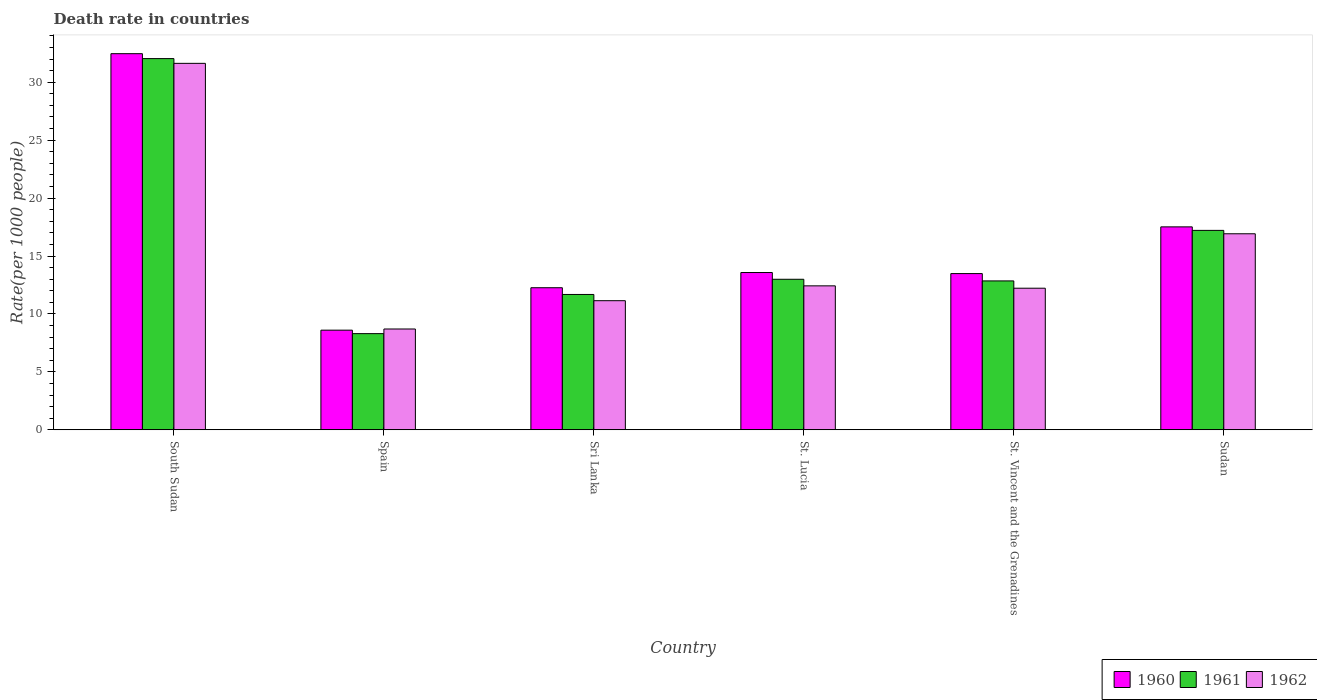How many groups of bars are there?
Your answer should be very brief. 6. Are the number of bars per tick equal to the number of legend labels?
Offer a terse response. Yes. How many bars are there on the 6th tick from the left?
Offer a terse response. 3. What is the label of the 4th group of bars from the left?
Give a very brief answer. St. Lucia. What is the death rate in 1960 in South Sudan?
Offer a very short reply. 32.46. Across all countries, what is the maximum death rate in 1961?
Provide a short and direct response. 32.04. Across all countries, what is the minimum death rate in 1961?
Offer a terse response. 8.3. In which country was the death rate in 1962 maximum?
Provide a short and direct response. South Sudan. What is the total death rate in 1961 in the graph?
Your answer should be compact. 95.07. What is the difference between the death rate in 1962 in South Sudan and that in Spain?
Provide a short and direct response. 22.93. What is the difference between the death rate in 1960 in St. Lucia and the death rate in 1962 in Spain?
Your response must be concise. 4.87. What is the average death rate in 1960 per country?
Provide a short and direct response. 16.32. What is the difference between the death rate of/in 1960 and death rate of/in 1962 in Spain?
Keep it short and to the point. -0.1. What is the ratio of the death rate in 1962 in St. Lucia to that in Sudan?
Make the answer very short. 0.73. Is the death rate in 1960 in St. Lucia less than that in St. Vincent and the Grenadines?
Offer a very short reply. No. What is the difference between the highest and the second highest death rate in 1961?
Offer a terse response. 14.83. What is the difference between the highest and the lowest death rate in 1962?
Make the answer very short. 22.93. What does the 2nd bar from the left in Sudan represents?
Give a very brief answer. 1961. What is the difference between two consecutive major ticks on the Y-axis?
Your response must be concise. 5. Are the values on the major ticks of Y-axis written in scientific E-notation?
Keep it short and to the point. No. Does the graph contain any zero values?
Your answer should be very brief. No. How are the legend labels stacked?
Give a very brief answer. Horizontal. What is the title of the graph?
Your answer should be very brief. Death rate in countries. Does "1975" appear as one of the legend labels in the graph?
Provide a short and direct response. No. What is the label or title of the Y-axis?
Provide a short and direct response. Rate(per 1000 people). What is the Rate(per 1000 people) in 1960 in South Sudan?
Your answer should be compact. 32.46. What is the Rate(per 1000 people) in 1961 in South Sudan?
Provide a short and direct response. 32.04. What is the Rate(per 1000 people) in 1962 in South Sudan?
Give a very brief answer. 31.63. What is the Rate(per 1000 people) in 1960 in Spain?
Your answer should be very brief. 8.6. What is the Rate(per 1000 people) of 1960 in Sri Lanka?
Your response must be concise. 12.26. What is the Rate(per 1000 people) of 1961 in Sri Lanka?
Provide a succinct answer. 11.68. What is the Rate(per 1000 people) in 1962 in Sri Lanka?
Provide a short and direct response. 11.14. What is the Rate(per 1000 people) of 1960 in St. Lucia?
Your answer should be very brief. 13.57. What is the Rate(per 1000 people) in 1961 in St. Lucia?
Provide a short and direct response. 12.99. What is the Rate(per 1000 people) in 1962 in St. Lucia?
Ensure brevity in your answer.  12.42. What is the Rate(per 1000 people) in 1960 in St. Vincent and the Grenadines?
Give a very brief answer. 13.48. What is the Rate(per 1000 people) of 1961 in St. Vincent and the Grenadines?
Your answer should be compact. 12.85. What is the Rate(per 1000 people) in 1962 in St. Vincent and the Grenadines?
Make the answer very short. 12.22. What is the Rate(per 1000 people) in 1960 in Sudan?
Your answer should be compact. 17.51. What is the Rate(per 1000 people) of 1961 in Sudan?
Your response must be concise. 17.21. What is the Rate(per 1000 people) in 1962 in Sudan?
Offer a very short reply. 16.92. Across all countries, what is the maximum Rate(per 1000 people) of 1960?
Provide a short and direct response. 32.46. Across all countries, what is the maximum Rate(per 1000 people) in 1961?
Ensure brevity in your answer.  32.04. Across all countries, what is the maximum Rate(per 1000 people) of 1962?
Offer a terse response. 31.63. Across all countries, what is the minimum Rate(per 1000 people) in 1960?
Provide a short and direct response. 8.6. What is the total Rate(per 1000 people) of 1960 in the graph?
Provide a short and direct response. 97.89. What is the total Rate(per 1000 people) of 1961 in the graph?
Provide a short and direct response. 95.07. What is the total Rate(per 1000 people) in 1962 in the graph?
Your answer should be compact. 93.03. What is the difference between the Rate(per 1000 people) of 1960 in South Sudan and that in Spain?
Make the answer very short. 23.86. What is the difference between the Rate(per 1000 people) in 1961 in South Sudan and that in Spain?
Offer a terse response. 23.74. What is the difference between the Rate(per 1000 people) in 1962 in South Sudan and that in Spain?
Provide a succinct answer. 22.93. What is the difference between the Rate(per 1000 people) in 1960 in South Sudan and that in Sri Lanka?
Give a very brief answer. 20.2. What is the difference between the Rate(per 1000 people) of 1961 in South Sudan and that in Sri Lanka?
Make the answer very short. 20.36. What is the difference between the Rate(per 1000 people) in 1962 in South Sudan and that in Sri Lanka?
Offer a very short reply. 20.48. What is the difference between the Rate(per 1000 people) of 1960 in South Sudan and that in St. Lucia?
Provide a short and direct response. 18.89. What is the difference between the Rate(per 1000 people) of 1961 in South Sudan and that in St. Lucia?
Keep it short and to the point. 19.05. What is the difference between the Rate(per 1000 people) of 1962 in South Sudan and that in St. Lucia?
Your answer should be compact. 19.2. What is the difference between the Rate(per 1000 people) in 1960 in South Sudan and that in St. Vincent and the Grenadines?
Keep it short and to the point. 18.98. What is the difference between the Rate(per 1000 people) of 1961 in South Sudan and that in St. Vincent and the Grenadines?
Offer a very short reply. 19.19. What is the difference between the Rate(per 1000 people) in 1962 in South Sudan and that in St. Vincent and the Grenadines?
Keep it short and to the point. 19.41. What is the difference between the Rate(per 1000 people) in 1960 in South Sudan and that in Sudan?
Provide a short and direct response. 14.95. What is the difference between the Rate(per 1000 people) of 1961 in South Sudan and that in Sudan?
Provide a short and direct response. 14.83. What is the difference between the Rate(per 1000 people) of 1962 in South Sudan and that in Sudan?
Your answer should be compact. 14.71. What is the difference between the Rate(per 1000 people) in 1960 in Spain and that in Sri Lanka?
Offer a very short reply. -3.66. What is the difference between the Rate(per 1000 people) of 1961 in Spain and that in Sri Lanka?
Offer a terse response. -3.38. What is the difference between the Rate(per 1000 people) in 1962 in Spain and that in Sri Lanka?
Make the answer very short. -2.44. What is the difference between the Rate(per 1000 people) of 1960 in Spain and that in St. Lucia?
Your response must be concise. -4.97. What is the difference between the Rate(per 1000 people) in 1961 in Spain and that in St. Lucia?
Your response must be concise. -4.69. What is the difference between the Rate(per 1000 people) in 1962 in Spain and that in St. Lucia?
Provide a short and direct response. -3.72. What is the difference between the Rate(per 1000 people) of 1960 in Spain and that in St. Vincent and the Grenadines?
Your answer should be compact. -4.88. What is the difference between the Rate(per 1000 people) in 1961 in Spain and that in St. Vincent and the Grenadines?
Provide a succinct answer. -4.55. What is the difference between the Rate(per 1000 people) in 1962 in Spain and that in St. Vincent and the Grenadines?
Your answer should be very brief. -3.52. What is the difference between the Rate(per 1000 people) of 1960 in Spain and that in Sudan?
Provide a short and direct response. -8.91. What is the difference between the Rate(per 1000 people) of 1961 in Spain and that in Sudan?
Keep it short and to the point. -8.91. What is the difference between the Rate(per 1000 people) in 1962 in Spain and that in Sudan?
Keep it short and to the point. -8.22. What is the difference between the Rate(per 1000 people) in 1960 in Sri Lanka and that in St. Lucia?
Your answer should be compact. -1.31. What is the difference between the Rate(per 1000 people) of 1961 in Sri Lanka and that in St. Lucia?
Keep it short and to the point. -1.31. What is the difference between the Rate(per 1000 people) in 1962 in Sri Lanka and that in St. Lucia?
Ensure brevity in your answer.  -1.28. What is the difference between the Rate(per 1000 people) in 1960 in Sri Lanka and that in St. Vincent and the Grenadines?
Offer a terse response. -1.22. What is the difference between the Rate(per 1000 people) in 1961 in Sri Lanka and that in St. Vincent and the Grenadines?
Give a very brief answer. -1.17. What is the difference between the Rate(per 1000 people) in 1962 in Sri Lanka and that in St. Vincent and the Grenadines?
Ensure brevity in your answer.  -1.08. What is the difference between the Rate(per 1000 people) of 1960 in Sri Lanka and that in Sudan?
Offer a very short reply. -5.25. What is the difference between the Rate(per 1000 people) of 1961 in Sri Lanka and that in Sudan?
Your answer should be very brief. -5.53. What is the difference between the Rate(per 1000 people) of 1962 in Sri Lanka and that in Sudan?
Ensure brevity in your answer.  -5.78. What is the difference between the Rate(per 1000 people) in 1960 in St. Lucia and that in St. Vincent and the Grenadines?
Offer a very short reply. 0.09. What is the difference between the Rate(per 1000 people) in 1961 in St. Lucia and that in St. Vincent and the Grenadines?
Your answer should be very brief. 0.14. What is the difference between the Rate(per 1000 people) in 1962 in St. Lucia and that in St. Vincent and the Grenadines?
Provide a succinct answer. 0.2. What is the difference between the Rate(per 1000 people) in 1960 in St. Lucia and that in Sudan?
Keep it short and to the point. -3.94. What is the difference between the Rate(per 1000 people) in 1961 in St. Lucia and that in Sudan?
Your response must be concise. -4.22. What is the difference between the Rate(per 1000 people) in 1962 in St. Lucia and that in Sudan?
Make the answer very short. -4.49. What is the difference between the Rate(per 1000 people) in 1960 in St. Vincent and the Grenadines and that in Sudan?
Give a very brief answer. -4.03. What is the difference between the Rate(per 1000 people) in 1961 in St. Vincent and the Grenadines and that in Sudan?
Your answer should be compact. -4.36. What is the difference between the Rate(per 1000 people) in 1962 in St. Vincent and the Grenadines and that in Sudan?
Ensure brevity in your answer.  -4.7. What is the difference between the Rate(per 1000 people) of 1960 in South Sudan and the Rate(per 1000 people) of 1961 in Spain?
Provide a succinct answer. 24.16. What is the difference between the Rate(per 1000 people) of 1960 in South Sudan and the Rate(per 1000 people) of 1962 in Spain?
Offer a very short reply. 23.76. What is the difference between the Rate(per 1000 people) of 1961 in South Sudan and the Rate(per 1000 people) of 1962 in Spain?
Your answer should be very brief. 23.34. What is the difference between the Rate(per 1000 people) in 1960 in South Sudan and the Rate(per 1000 people) in 1961 in Sri Lanka?
Your response must be concise. 20.78. What is the difference between the Rate(per 1000 people) of 1960 in South Sudan and the Rate(per 1000 people) of 1962 in Sri Lanka?
Your response must be concise. 21.32. What is the difference between the Rate(per 1000 people) in 1961 in South Sudan and the Rate(per 1000 people) in 1962 in Sri Lanka?
Your answer should be very brief. 20.89. What is the difference between the Rate(per 1000 people) in 1960 in South Sudan and the Rate(per 1000 people) in 1961 in St. Lucia?
Provide a succinct answer. 19.47. What is the difference between the Rate(per 1000 people) of 1960 in South Sudan and the Rate(per 1000 people) of 1962 in St. Lucia?
Your response must be concise. 20.04. What is the difference between the Rate(per 1000 people) in 1961 in South Sudan and the Rate(per 1000 people) in 1962 in St. Lucia?
Give a very brief answer. 19.61. What is the difference between the Rate(per 1000 people) in 1960 in South Sudan and the Rate(per 1000 people) in 1961 in St. Vincent and the Grenadines?
Provide a short and direct response. 19.61. What is the difference between the Rate(per 1000 people) of 1960 in South Sudan and the Rate(per 1000 people) of 1962 in St. Vincent and the Grenadines?
Your answer should be compact. 20.24. What is the difference between the Rate(per 1000 people) in 1961 in South Sudan and the Rate(per 1000 people) in 1962 in St. Vincent and the Grenadines?
Your response must be concise. 19.82. What is the difference between the Rate(per 1000 people) of 1960 in South Sudan and the Rate(per 1000 people) of 1961 in Sudan?
Offer a terse response. 15.25. What is the difference between the Rate(per 1000 people) in 1960 in South Sudan and the Rate(per 1000 people) in 1962 in Sudan?
Your response must be concise. 15.54. What is the difference between the Rate(per 1000 people) in 1961 in South Sudan and the Rate(per 1000 people) in 1962 in Sudan?
Provide a succinct answer. 15.12. What is the difference between the Rate(per 1000 people) in 1960 in Spain and the Rate(per 1000 people) in 1961 in Sri Lanka?
Your answer should be very brief. -3.08. What is the difference between the Rate(per 1000 people) in 1960 in Spain and the Rate(per 1000 people) in 1962 in Sri Lanka?
Ensure brevity in your answer.  -2.54. What is the difference between the Rate(per 1000 people) in 1961 in Spain and the Rate(per 1000 people) in 1962 in Sri Lanka?
Provide a short and direct response. -2.84. What is the difference between the Rate(per 1000 people) in 1960 in Spain and the Rate(per 1000 people) in 1961 in St. Lucia?
Provide a short and direct response. -4.39. What is the difference between the Rate(per 1000 people) in 1960 in Spain and the Rate(per 1000 people) in 1962 in St. Lucia?
Offer a very short reply. -3.82. What is the difference between the Rate(per 1000 people) of 1961 in Spain and the Rate(per 1000 people) of 1962 in St. Lucia?
Provide a short and direct response. -4.12. What is the difference between the Rate(per 1000 people) of 1960 in Spain and the Rate(per 1000 people) of 1961 in St. Vincent and the Grenadines?
Ensure brevity in your answer.  -4.25. What is the difference between the Rate(per 1000 people) of 1960 in Spain and the Rate(per 1000 people) of 1962 in St. Vincent and the Grenadines?
Provide a short and direct response. -3.62. What is the difference between the Rate(per 1000 people) of 1961 in Spain and the Rate(per 1000 people) of 1962 in St. Vincent and the Grenadines?
Your answer should be very brief. -3.92. What is the difference between the Rate(per 1000 people) in 1960 in Spain and the Rate(per 1000 people) in 1961 in Sudan?
Ensure brevity in your answer.  -8.61. What is the difference between the Rate(per 1000 people) of 1960 in Spain and the Rate(per 1000 people) of 1962 in Sudan?
Keep it short and to the point. -8.32. What is the difference between the Rate(per 1000 people) of 1961 in Spain and the Rate(per 1000 people) of 1962 in Sudan?
Your answer should be very brief. -8.62. What is the difference between the Rate(per 1000 people) in 1960 in Sri Lanka and the Rate(per 1000 people) in 1961 in St. Lucia?
Your answer should be very brief. -0.73. What is the difference between the Rate(per 1000 people) of 1960 in Sri Lanka and the Rate(per 1000 people) of 1962 in St. Lucia?
Ensure brevity in your answer.  -0.16. What is the difference between the Rate(per 1000 people) of 1961 in Sri Lanka and the Rate(per 1000 people) of 1962 in St. Lucia?
Provide a succinct answer. -0.74. What is the difference between the Rate(per 1000 people) of 1960 in Sri Lanka and the Rate(per 1000 people) of 1961 in St. Vincent and the Grenadines?
Your answer should be very brief. -0.59. What is the difference between the Rate(per 1000 people) of 1960 in Sri Lanka and the Rate(per 1000 people) of 1962 in St. Vincent and the Grenadines?
Provide a succinct answer. 0.04. What is the difference between the Rate(per 1000 people) of 1961 in Sri Lanka and the Rate(per 1000 people) of 1962 in St. Vincent and the Grenadines?
Your answer should be compact. -0.54. What is the difference between the Rate(per 1000 people) of 1960 in Sri Lanka and the Rate(per 1000 people) of 1961 in Sudan?
Keep it short and to the point. -4.95. What is the difference between the Rate(per 1000 people) in 1960 in Sri Lanka and the Rate(per 1000 people) in 1962 in Sudan?
Offer a terse response. -4.66. What is the difference between the Rate(per 1000 people) of 1961 in Sri Lanka and the Rate(per 1000 people) of 1962 in Sudan?
Ensure brevity in your answer.  -5.24. What is the difference between the Rate(per 1000 people) in 1960 in St. Lucia and the Rate(per 1000 people) in 1961 in St. Vincent and the Grenadines?
Your response must be concise. 0.72. What is the difference between the Rate(per 1000 people) of 1960 in St. Lucia and the Rate(per 1000 people) of 1962 in St. Vincent and the Grenadines?
Offer a terse response. 1.35. What is the difference between the Rate(per 1000 people) of 1961 in St. Lucia and the Rate(per 1000 people) of 1962 in St. Vincent and the Grenadines?
Ensure brevity in your answer.  0.77. What is the difference between the Rate(per 1000 people) in 1960 in St. Lucia and the Rate(per 1000 people) in 1961 in Sudan?
Keep it short and to the point. -3.64. What is the difference between the Rate(per 1000 people) of 1960 in St. Lucia and the Rate(per 1000 people) of 1962 in Sudan?
Make the answer very short. -3.34. What is the difference between the Rate(per 1000 people) of 1961 in St. Lucia and the Rate(per 1000 people) of 1962 in Sudan?
Keep it short and to the point. -3.93. What is the difference between the Rate(per 1000 people) of 1960 in St. Vincent and the Grenadines and the Rate(per 1000 people) of 1961 in Sudan?
Offer a very short reply. -3.73. What is the difference between the Rate(per 1000 people) of 1960 in St. Vincent and the Grenadines and the Rate(per 1000 people) of 1962 in Sudan?
Offer a very short reply. -3.44. What is the difference between the Rate(per 1000 people) in 1961 in St. Vincent and the Grenadines and the Rate(per 1000 people) in 1962 in Sudan?
Offer a very short reply. -4.07. What is the average Rate(per 1000 people) of 1960 per country?
Keep it short and to the point. 16.32. What is the average Rate(per 1000 people) of 1961 per country?
Your response must be concise. 15.85. What is the average Rate(per 1000 people) in 1962 per country?
Ensure brevity in your answer.  15.51. What is the difference between the Rate(per 1000 people) in 1960 and Rate(per 1000 people) in 1961 in South Sudan?
Make the answer very short. 0.42. What is the difference between the Rate(per 1000 people) of 1960 and Rate(per 1000 people) of 1962 in South Sudan?
Keep it short and to the point. 0.83. What is the difference between the Rate(per 1000 people) in 1961 and Rate(per 1000 people) in 1962 in South Sudan?
Make the answer very short. 0.41. What is the difference between the Rate(per 1000 people) in 1960 and Rate(per 1000 people) in 1962 in Spain?
Give a very brief answer. -0.1. What is the difference between the Rate(per 1000 people) in 1961 and Rate(per 1000 people) in 1962 in Spain?
Your answer should be compact. -0.4. What is the difference between the Rate(per 1000 people) of 1960 and Rate(per 1000 people) of 1961 in Sri Lanka?
Your answer should be compact. 0.58. What is the difference between the Rate(per 1000 people) in 1960 and Rate(per 1000 people) in 1962 in Sri Lanka?
Offer a very short reply. 1.12. What is the difference between the Rate(per 1000 people) in 1961 and Rate(per 1000 people) in 1962 in Sri Lanka?
Provide a short and direct response. 0.54. What is the difference between the Rate(per 1000 people) in 1960 and Rate(per 1000 people) in 1961 in St. Lucia?
Keep it short and to the point. 0.58. What is the difference between the Rate(per 1000 people) of 1960 and Rate(per 1000 people) of 1962 in St. Lucia?
Your response must be concise. 1.15. What is the difference between the Rate(per 1000 people) in 1961 and Rate(per 1000 people) in 1962 in St. Lucia?
Make the answer very short. 0.57. What is the difference between the Rate(per 1000 people) of 1960 and Rate(per 1000 people) of 1961 in St. Vincent and the Grenadines?
Keep it short and to the point. 0.63. What is the difference between the Rate(per 1000 people) of 1960 and Rate(per 1000 people) of 1962 in St. Vincent and the Grenadines?
Keep it short and to the point. 1.26. What is the difference between the Rate(per 1000 people) in 1961 and Rate(per 1000 people) in 1962 in St. Vincent and the Grenadines?
Your answer should be compact. 0.63. What is the difference between the Rate(per 1000 people) in 1960 and Rate(per 1000 people) in 1961 in Sudan?
Ensure brevity in your answer.  0.3. What is the difference between the Rate(per 1000 people) of 1960 and Rate(per 1000 people) of 1962 in Sudan?
Your response must be concise. 0.6. What is the difference between the Rate(per 1000 people) of 1961 and Rate(per 1000 people) of 1962 in Sudan?
Your response must be concise. 0.29. What is the ratio of the Rate(per 1000 people) in 1960 in South Sudan to that in Spain?
Offer a terse response. 3.77. What is the ratio of the Rate(per 1000 people) in 1961 in South Sudan to that in Spain?
Provide a short and direct response. 3.86. What is the ratio of the Rate(per 1000 people) of 1962 in South Sudan to that in Spain?
Keep it short and to the point. 3.64. What is the ratio of the Rate(per 1000 people) in 1960 in South Sudan to that in Sri Lanka?
Ensure brevity in your answer.  2.65. What is the ratio of the Rate(per 1000 people) of 1961 in South Sudan to that in Sri Lanka?
Your answer should be compact. 2.74. What is the ratio of the Rate(per 1000 people) of 1962 in South Sudan to that in Sri Lanka?
Your answer should be very brief. 2.84. What is the ratio of the Rate(per 1000 people) of 1960 in South Sudan to that in St. Lucia?
Your answer should be very brief. 2.39. What is the ratio of the Rate(per 1000 people) of 1961 in South Sudan to that in St. Lucia?
Offer a terse response. 2.47. What is the ratio of the Rate(per 1000 people) of 1962 in South Sudan to that in St. Lucia?
Make the answer very short. 2.55. What is the ratio of the Rate(per 1000 people) in 1960 in South Sudan to that in St. Vincent and the Grenadines?
Keep it short and to the point. 2.41. What is the ratio of the Rate(per 1000 people) of 1961 in South Sudan to that in St. Vincent and the Grenadines?
Offer a very short reply. 2.49. What is the ratio of the Rate(per 1000 people) in 1962 in South Sudan to that in St. Vincent and the Grenadines?
Keep it short and to the point. 2.59. What is the ratio of the Rate(per 1000 people) of 1960 in South Sudan to that in Sudan?
Offer a very short reply. 1.85. What is the ratio of the Rate(per 1000 people) in 1961 in South Sudan to that in Sudan?
Keep it short and to the point. 1.86. What is the ratio of the Rate(per 1000 people) of 1962 in South Sudan to that in Sudan?
Make the answer very short. 1.87. What is the ratio of the Rate(per 1000 people) in 1960 in Spain to that in Sri Lanka?
Make the answer very short. 0.7. What is the ratio of the Rate(per 1000 people) of 1961 in Spain to that in Sri Lanka?
Offer a very short reply. 0.71. What is the ratio of the Rate(per 1000 people) of 1962 in Spain to that in Sri Lanka?
Offer a very short reply. 0.78. What is the ratio of the Rate(per 1000 people) of 1960 in Spain to that in St. Lucia?
Your response must be concise. 0.63. What is the ratio of the Rate(per 1000 people) of 1961 in Spain to that in St. Lucia?
Provide a short and direct response. 0.64. What is the ratio of the Rate(per 1000 people) in 1962 in Spain to that in St. Lucia?
Your answer should be compact. 0.7. What is the ratio of the Rate(per 1000 people) of 1960 in Spain to that in St. Vincent and the Grenadines?
Make the answer very short. 0.64. What is the ratio of the Rate(per 1000 people) in 1961 in Spain to that in St. Vincent and the Grenadines?
Make the answer very short. 0.65. What is the ratio of the Rate(per 1000 people) of 1962 in Spain to that in St. Vincent and the Grenadines?
Give a very brief answer. 0.71. What is the ratio of the Rate(per 1000 people) of 1960 in Spain to that in Sudan?
Offer a very short reply. 0.49. What is the ratio of the Rate(per 1000 people) in 1961 in Spain to that in Sudan?
Offer a very short reply. 0.48. What is the ratio of the Rate(per 1000 people) of 1962 in Spain to that in Sudan?
Your answer should be very brief. 0.51. What is the ratio of the Rate(per 1000 people) in 1960 in Sri Lanka to that in St. Lucia?
Provide a short and direct response. 0.9. What is the ratio of the Rate(per 1000 people) in 1961 in Sri Lanka to that in St. Lucia?
Offer a very short reply. 0.9. What is the ratio of the Rate(per 1000 people) of 1962 in Sri Lanka to that in St. Lucia?
Your response must be concise. 0.9. What is the ratio of the Rate(per 1000 people) in 1960 in Sri Lanka to that in St. Vincent and the Grenadines?
Make the answer very short. 0.91. What is the ratio of the Rate(per 1000 people) in 1961 in Sri Lanka to that in St. Vincent and the Grenadines?
Provide a short and direct response. 0.91. What is the ratio of the Rate(per 1000 people) of 1962 in Sri Lanka to that in St. Vincent and the Grenadines?
Your answer should be compact. 0.91. What is the ratio of the Rate(per 1000 people) in 1960 in Sri Lanka to that in Sudan?
Make the answer very short. 0.7. What is the ratio of the Rate(per 1000 people) in 1961 in Sri Lanka to that in Sudan?
Offer a very short reply. 0.68. What is the ratio of the Rate(per 1000 people) in 1962 in Sri Lanka to that in Sudan?
Your answer should be very brief. 0.66. What is the ratio of the Rate(per 1000 people) in 1960 in St. Lucia to that in St. Vincent and the Grenadines?
Offer a terse response. 1.01. What is the ratio of the Rate(per 1000 people) of 1962 in St. Lucia to that in St. Vincent and the Grenadines?
Provide a short and direct response. 1.02. What is the ratio of the Rate(per 1000 people) of 1960 in St. Lucia to that in Sudan?
Make the answer very short. 0.78. What is the ratio of the Rate(per 1000 people) of 1961 in St. Lucia to that in Sudan?
Provide a short and direct response. 0.75. What is the ratio of the Rate(per 1000 people) of 1962 in St. Lucia to that in Sudan?
Offer a terse response. 0.73. What is the ratio of the Rate(per 1000 people) of 1960 in St. Vincent and the Grenadines to that in Sudan?
Ensure brevity in your answer.  0.77. What is the ratio of the Rate(per 1000 people) of 1961 in St. Vincent and the Grenadines to that in Sudan?
Offer a very short reply. 0.75. What is the ratio of the Rate(per 1000 people) in 1962 in St. Vincent and the Grenadines to that in Sudan?
Your answer should be compact. 0.72. What is the difference between the highest and the second highest Rate(per 1000 people) of 1960?
Provide a succinct answer. 14.95. What is the difference between the highest and the second highest Rate(per 1000 people) in 1961?
Offer a terse response. 14.83. What is the difference between the highest and the second highest Rate(per 1000 people) in 1962?
Provide a short and direct response. 14.71. What is the difference between the highest and the lowest Rate(per 1000 people) of 1960?
Ensure brevity in your answer.  23.86. What is the difference between the highest and the lowest Rate(per 1000 people) in 1961?
Your answer should be compact. 23.74. What is the difference between the highest and the lowest Rate(per 1000 people) of 1962?
Provide a succinct answer. 22.93. 